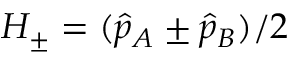<formula> <loc_0><loc_0><loc_500><loc_500>H _ { \pm } = ( \hat { p } _ { A } \pm \hat { p } _ { B } ) / 2</formula> 